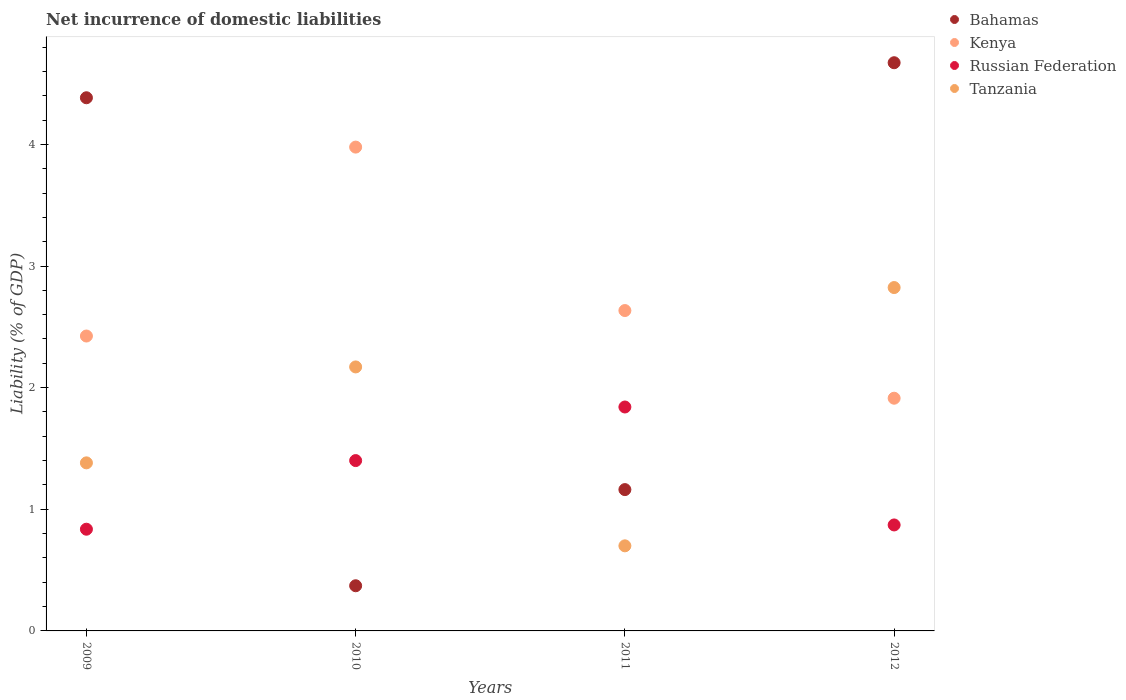How many different coloured dotlines are there?
Give a very brief answer. 4. Is the number of dotlines equal to the number of legend labels?
Provide a succinct answer. Yes. What is the net incurrence of domestic liabilities in Russian Federation in 2010?
Ensure brevity in your answer.  1.4. Across all years, what is the maximum net incurrence of domestic liabilities in Russian Federation?
Ensure brevity in your answer.  1.84. Across all years, what is the minimum net incurrence of domestic liabilities in Russian Federation?
Your answer should be compact. 0.84. In which year was the net incurrence of domestic liabilities in Tanzania maximum?
Make the answer very short. 2012. What is the total net incurrence of domestic liabilities in Tanzania in the graph?
Provide a short and direct response. 7.07. What is the difference between the net incurrence of domestic liabilities in Russian Federation in 2009 and that in 2011?
Offer a very short reply. -1. What is the difference between the net incurrence of domestic liabilities in Russian Federation in 2009 and the net incurrence of domestic liabilities in Kenya in 2012?
Offer a terse response. -1.08. What is the average net incurrence of domestic liabilities in Bahamas per year?
Keep it short and to the point. 2.65. In the year 2012, what is the difference between the net incurrence of domestic liabilities in Tanzania and net incurrence of domestic liabilities in Russian Federation?
Make the answer very short. 1.95. In how many years, is the net incurrence of domestic liabilities in Russian Federation greater than 1 %?
Offer a terse response. 2. What is the ratio of the net incurrence of domestic liabilities in Bahamas in 2010 to that in 2011?
Offer a very short reply. 0.32. What is the difference between the highest and the second highest net incurrence of domestic liabilities in Tanzania?
Your answer should be compact. 0.65. What is the difference between the highest and the lowest net incurrence of domestic liabilities in Tanzania?
Your answer should be compact. 2.12. In how many years, is the net incurrence of domestic liabilities in Bahamas greater than the average net incurrence of domestic liabilities in Bahamas taken over all years?
Your answer should be compact. 2. Is the sum of the net incurrence of domestic liabilities in Kenya in 2010 and 2012 greater than the maximum net incurrence of domestic liabilities in Bahamas across all years?
Ensure brevity in your answer.  Yes. Is it the case that in every year, the sum of the net incurrence of domestic liabilities in Kenya and net incurrence of domestic liabilities in Bahamas  is greater than the sum of net incurrence of domestic liabilities in Russian Federation and net incurrence of domestic liabilities in Tanzania?
Your answer should be very brief. Yes. Is the net incurrence of domestic liabilities in Tanzania strictly greater than the net incurrence of domestic liabilities in Russian Federation over the years?
Your answer should be compact. No. Is the net incurrence of domestic liabilities in Kenya strictly less than the net incurrence of domestic liabilities in Tanzania over the years?
Provide a succinct answer. No. How many dotlines are there?
Make the answer very short. 4. What is the difference between two consecutive major ticks on the Y-axis?
Offer a terse response. 1. Does the graph contain grids?
Offer a very short reply. No. How many legend labels are there?
Offer a very short reply. 4. What is the title of the graph?
Provide a succinct answer. Net incurrence of domestic liabilities. What is the label or title of the X-axis?
Your answer should be very brief. Years. What is the label or title of the Y-axis?
Ensure brevity in your answer.  Liability (% of GDP). What is the Liability (% of GDP) of Bahamas in 2009?
Make the answer very short. 4.38. What is the Liability (% of GDP) of Kenya in 2009?
Offer a terse response. 2.42. What is the Liability (% of GDP) in Russian Federation in 2009?
Provide a short and direct response. 0.84. What is the Liability (% of GDP) in Tanzania in 2009?
Keep it short and to the point. 1.38. What is the Liability (% of GDP) in Bahamas in 2010?
Provide a short and direct response. 0.37. What is the Liability (% of GDP) of Kenya in 2010?
Provide a succinct answer. 3.98. What is the Liability (% of GDP) of Russian Federation in 2010?
Your response must be concise. 1.4. What is the Liability (% of GDP) in Tanzania in 2010?
Offer a terse response. 2.17. What is the Liability (% of GDP) in Bahamas in 2011?
Your answer should be very brief. 1.16. What is the Liability (% of GDP) of Kenya in 2011?
Your answer should be very brief. 2.63. What is the Liability (% of GDP) of Russian Federation in 2011?
Provide a short and direct response. 1.84. What is the Liability (% of GDP) in Tanzania in 2011?
Provide a short and direct response. 0.7. What is the Liability (% of GDP) of Bahamas in 2012?
Provide a succinct answer. 4.67. What is the Liability (% of GDP) of Kenya in 2012?
Your response must be concise. 1.91. What is the Liability (% of GDP) of Russian Federation in 2012?
Provide a succinct answer. 0.87. What is the Liability (% of GDP) of Tanzania in 2012?
Provide a succinct answer. 2.82. Across all years, what is the maximum Liability (% of GDP) in Bahamas?
Your response must be concise. 4.67. Across all years, what is the maximum Liability (% of GDP) in Kenya?
Give a very brief answer. 3.98. Across all years, what is the maximum Liability (% of GDP) of Russian Federation?
Provide a short and direct response. 1.84. Across all years, what is the maximum Liability (% of GDP) of Tanzania?
Your response must be concise. 2.82. Across all years, what is the minimum Liability (% of GDP) of Bahamas?
Your answer should be very brief. 0.37. Across all years, what is the minimum Liability (% of GDP) of Kenya?
Provide a succinct answer. 1.91. Across all years, what is the minimum Liability (% of GDP) in Russian Federation?
Your answer should be very brief. 0.84. Across all years, what is the minimum Liability (% of GDP) in Tanzania?
Offer a terse response. 0.7. What is the total Liability (% of GDP) of Bahamas in the graph?
Offer a terse response. 10.59. What is the total Liability (% of GDP) in Kenya in the graph?
Your answer should be compact. 10.95. What is the total Liability (% of GDP) in Russian Federation in the graph?
Ensure brevity in your answer.  4.95. What is the total Liability (% of GDP) of Tanzania in the graph?
Offer a terse response. 7.07. What is the difference between the Liability (% of GDP) in Bahamas in 2009 and that in 2010?
Make the answer very short. 4.01. What is the difference between the Liability (% of GDP) in Kenya in 2009 and that in 2010?
Your answer should be compact. -1.55. What is the difference between the Liability (% of GDP) in Russian Federation in 2009 and that in 2010?
Provide a succinct answer. -0.56. What is the difference between the Liability (% of GDP) in Tanzania in 2009 and that in 2010?
Offer a terse response. -0.79. What is the difference between the Liability (% of GDP) in Bahamas in 2009 and that in 2011?
Your response must be concise. 3.22. What is the difference between the Liability (% of GDP) of Kenya in 2009 and that in 2011?
Make the answer very short. -0.21. What is the difference between the Liability (% of GDP) in Russian Federation in 2009 and that in 2011?
Keep it short and to the point. -1. What is the difference between the Liability (% of GDP) in Tanzania in 2009 and that in 2011?
Your answer should be very brief. 0.68. What is the difference between the Liability (% of GDP) of Bahamas in 2009 and that in 2012?
Keep it short and to the point. -0.29. What is the difference between the Liability (% of GDP) in Kenya in 2009 and that in 2012?
Keep it short and to the point. 0.51. What is the difference between the Liability (% of GDP) of Russian Federation in 2009 and that in 2012?
Give a very brief answer. -0.04. What is the difference between the Liability (% of GDP) of Tanzania in 2009 and that in 2012?
Offer a terse response. -1.44. What is the difference between the Liability (% of GDP) of Bahamas in 2010 and that in 2011?
Offer a terse response. -0.79. What is the difference between the Liability (% of GDP) of Kenya in 2010 and that in 2011?
Your answer should be compact. 1.34. What is the difference between the Liability (% of GDP) in Russian Federation in 2010 and that in 2011?
Make the answer very short. -0.44. What is the difference between the Liability (% of GDP) of Tanzania in 2010 and that in 2011?
Your answer should be compact. 1.47. What is the difference between the Liability (% of GDP) in Bahamas in 2010 and that in 2012?
Offer a terse response. -4.3. What is the difference between the Liability (% of GDP) in Kenya in 2010 and that in 2012?
Give a very brief answer. 2.06. What is the difference between the Liability (% of GDP) of Russian Federation in 2010 and that in 2012?
Give a very brief answer. 0.53. What is the difference between the Liability (% of GDP) of Tanzania in 2010 and that in 2012?
Your answer should be very brief. -0.65. What is the difference between the Liability (% of GDP) of Bahamas in 2011 and that in 2012?
Offer a terse response. -3.51. What is the difference between the Liability (% of GDP) of Kenya in 2011 and that in 2012?
Offer a very short reply. 0.72. What is the difference between the Liability (% of GDP) in Russian Federation in 2011 and that in 2012?
Your answer should be very brief. 0.97. What is the difference between the Liability (% of GDP) in Tanzania in 2011 and that in 2012?
Provide a short and direct response. -2.12. What is the difference between the Liability (% of GDP) in Bahamas in 2009 and the Liability (% of GDP) in Kenya in 2010?
Give a very brief answer. 0.41. What is the difference between the Liability (% of GDP) in Bahamas in 2009 and the Liability (% of GDP) in Russian Federation in 2010?
Your answer should be very brief. 2.98. What is the difference between the Liability (% of GDP) of Bahamas in 2009 and the Liability (% of GDP) of Tanzania in 2010?
Ensure brevity in your answer.  2.21. What is the difference between the Liability (% of GDP) in Kenya in 2009 and the Liability (% of GDP) in Tanzania in 2010?
Offer a terse response. 0.25. What is the difference between the Liability (% of GDP) of Russian Federation in 2009 and the Liability (% of GDP) of Tanzania in 2010?
Provide a short and direct response. -1.33. What is the difference between the Liability (% of GDP) of Bahamas in 2009 and the Liability (% of GDP) of Kenya in 2011?
Keep it short and to the point. 1.75. What is the difference between the Liability (% of GDP) in Bahamas in 2009 and the Liability (% of GDP) in Russian Federation in 2011?
Your answer should be compact. 2.54. What is the difference between the Liability (% of GDP) of Bahamas in 2009 and the Liability (% of GDP) of Tanzania in 2011?
Give a very brief answer. 3.68. What is the difference between the Liability (% of GDP) of Kenya in 2009 and the Liability (% of GDP) of Russian Federation in 2011?
Keep it short and to the point. 0.58. What is the difference between the Liability (% of GDP) of Kenya in 2009 and the Liability (% of GDP) of Tanzania in 2011?
Offer a terse response. 1.72. What is the difference between the Liability (% of GDP) in Russian Federation in 2009 and the Liability (% of GDP) in Tanzania in 2011?
Your response must be concise. 0.14. What is the difference between the Liability (% of GDP) in Bahamas in 2009 and the Liability (% of GDP) in Kenya in 2012?
Offer a terse response. 2.47. What is the difference between the Liability (% of GDP) of Bahamas in 2009 and the Liability (% of GDP) of Russian Federation in 2012?
Your answer should be very brief. 3.51. What is the difference between the Liability (% of GDP) of Bahamas in 2009 and the Liability (% of GDP) of Tanzania in 2012?
Your answer should be very brief. 1.56. What is the difference between the Liability (% of GDP) in Kenya in 2009 and the Liability (% of GDP) in Russian Federation in 2012?
Your response must be concise. 1.55. What is the difference between the Liability (% of GDP) in Kenya in 2009 and the Liability (% of GDP) in Tanzania in 2012?
Offer a terse response. -0.4. What is the difference between the Liability (% of GDP) of Russian Federation in 2009 and the Liability (% of GDP) of Tanzania in 2012?
Keep it short and to the point. -1.99. What is the difference between the Liability (% of GDP) of Bahamas in 2010 and the Liability (% of GDP) of Kenya in 2011?
Your answer should be compact. -2.26. What is the difference between the Liability (% of GDP) in Bahamas in 2010 and the Liability (% of GDP) in Russian Federation in 2011?
Offer a terse response. -1.47. What is the difference between the Liability (% of GDP) of Bahamas in 2010 and the Liability (% of GDP) of Tanzania in 2011?
Make the answer very short. -0.33. What is the difference between the Liability (% of GDP) in Kenya in 2010 and the Liability (% of GDP) in Russian Federation in 2011?
Your answer should be very brief. 2.14. What is the difference between the Liability (% of GDP) in Kenya in 2010 and the Liability (% of GDP) in Tanzania in 2011?
Make the answer very short. 3.28. What is the difference between the Liability (% of GDP) in Russian Federation in 2010 and the Liability (% of GDP) in Tanzania in 2011?
Provide a short and direct response. 0.7. What is the difference between the Liability (% of GDP) of Bahamas in 2010 and the Liability (% of GDP) of Kenya in 2012?
Give a very brief answer. -1.54. What is the difference between the Liability (% of GDP) of Bahamas in 2010 and the Liability (% of GDP) of Russian Federation in 2012?
Keep it short and to the point. -0.5. What is the difference between the Liability (% of GDP) in Bahamas in 2010 and the Liability (% of GDP) in Tanzania in 2012?
Your answer should be very brief. -2.45. What is the difference between the Liability (% of GDP) of Kenya in 2010 and the Liability (% of GDP) of Russian Federation in 2012?
Provide a short and direct response. 3.11. What is the difference between the Liability (% of GDP) of Kenya in 2010 and the Liability (% of GDP) of Tanzania in 2012?
Offer a very short reply. 1.15. What is the difference between the Liability (% of GDP) of Russian Federation in 2010 and the Liability (% of GDP) of Tanzania in 2012?
Provide a short and direct response. -1.42. What is the difference between the Liability (% of GDP) of Bahamas in 2011 and the Liability (% of GDP) of Kenya in 2012?
Offer a very short reply. -0.75. What is the difference between the Liability (% of GDP) of Bahamas in 2011 and the Liability (% of GDP) of Russian Federation in 2012?
Your answer should be compact. 0.29. What is the difference between the Liability (% of GDP) in Bahamas in 2011 and the Liability (% of GDP) in Tanzania in 2012?
Make the answer very short. -1.66. What is the difference between the Liability (% of GDP) in Kenya in 2011 and the Liability (% of GDP) in Russian Federation in 2012?
Keep it short and to the point. 1.76. What is the difference between the Liability (% of GDP) of Kenya in 2011 and the Liability (% of GDP) of Tanzania in 2012?
Give a very brief answer. -0.19. What is the difference between the Liability (% of GDP) of Russian Federation in 2011 and the Liability (% of GDP) of Tanzania in 2012?
Offer a very short reply. -0.98. What is the average Liability (% of GDP) of Bahamas per year?
Your answer should be compact. 2.65. What is the average Liability (% of GDP) of Kenya per year?
Offer a terse response. 2.74. What is the average Liability (% of GDP) of Russian Federation per year?
Your answer should be very brief. 1.24. What is the average Liability (% of GDP) of Tanzania per year?
Give a very brief answer. 1.77. In the year 2009, what is the difference between the Liability (% of GDP) in Bahamas and Liability (% of GDP) in Kenya?
Offer a terse response. 1.96. In the year 2009, what is the difference between the Liability (% of GDP) of Bahamas and Liability (% of GDP) of Russian Federation?
Give a very brief answer. 3.55. In the year 2009, what is the difference between the Liability (% of GDP) in Bahamas and Liability (% of GDP) in Tanzania?
Provide a succinct answer. 3. In the year 2009, what is the difference between the Liability (% of GDP) in Kenya and Liability (% of GDP) in Russian Federation?
Keep it short and to the point. 1.59. In the year 2009, what is the difference between the Liability (% of GDP) in Kenya and Liability (% of GDP) in Tanzania?
Provide a short and direct response. 1.04. In the year 2009, what is the difference between the Liability (% of GDP) of Russian Federation and Liability (% of GDP) of Tanzania?
Provide a succinct answer. -0.55. In the year 2010, what is the difference between the Liability (% of GDP) of Bahamas and Liability (% of GDP) of Kenya?
Keep it short and to the point. -3.61. In the year 2010, what is the difference between the Liability (% of GDP) in Bahamas and Liability (% of GDP) in Russian Federation?
Provide a short and direct response. -1.03. In the year 2010, what is the difference between the Liability (% of GDP) of Bahamas and Liability (% of GDP) of Tanzania?
Offer a terse response. -1.8. In the year 2010, what is the difference between the Liability (% of GDP) of Kenya and Liability (% of GDP) of Russian Federation?
Your response must be concise. 2.58. In the year 2010, what is the difference between the Liability (% of GDP) of Kenya and Liability (% of GDP) of Tanzania?
Provide a succinct answer. 1.81. In the year 2010, what is the difference between the Liability (% of GDP) in Russian Federation and Liability (% of GDP) in Tanzania?
Ensure brevity in your answer.  -0.77. In the year 2011, what is the difference between the Liability (% of GDP) of Bahamas and Liability (% of GDP) of Kenya?
Provide a short and direct response. -1.47. In the year 2011, what is the difference between the Liability (% of GDP) in Bahamas and Liability (% of GDP) in Russian Federation?
Your response must be concise. -0.68. In the year 2011, what is the difference between the Liability (% of GDP) of Bahamas and Liability (% of GDP) of Tanzania?
Make the answer very short. 0.46. In the year 2011, what is the difference between the Liability (% of GDP) of Kenya and Liability (% of GDP) of Russian Federation?
Offer a terse response. 0.79. In the year 2011, what is the difference between the Liability (% of GDP) of Kenya and Liability (% of GDP) of Tanzania?
Keep it short and to the point. 1.93. In the year 2011, what is the difference between the Liability (% of GDP) in Russian Federation and Liability (% of GDP) in Tanzania?
Give a very brief answer. 1.14. In the year 2012, what is the difference between the Liability (% of GDP) of Bahamas and Liability (% of GDP) of Kenya?
Offer a very short reply. 2.76. In the year 2012, what is the difference between the Liability (% of GDP) of Bahamas and Liability (% of GDP) of Russian Federation?
Provide a short and direct response. 3.8. In the year 2012, what is the difference between the Liability (% of GDP) in Bahamas and Liability (% of GDP) in Tanzania?
Offer a terse response. 1.85. In the year 2012, what is the difference between the Liability (% of GDP) of Kenya and Liability (% of GDP) of Russian Federation?
Your answer should be very brief. 1.04. In the year 2012, what is the difference between the Liability (% of GDP) in Kenya and Liability (% of GDP) in Tanzania?
Provide a succinct answer. -0.91. In the year 2012, what is the difference between the Liability (% of GDP) of Russian Federation and Liability (% of GDP) of Tanzania?
Provide a succinct answer. -1.95. What is the ratio of the Liability (% of GDP) of Bahamas in 2009 to that in 2010?
Ensure brevity in your answer.  11.8. What is the ratio of the Liability (% of GDP) of Kenya in 2009 to that in 2010?
Provide a succinct answer. 0.61. What is the ratio of the Liability (% of GDP) of Russian Federation in 2009 to that in 2010?
Your answer should be very brief. 0.6. What is the ratio of the Liability (% of GDP) in Tanzania in 2009 to that in 2010?
Your answer should be compact. 0.64. What is the ratio of the Liability (% of GDP) in Bahamas in 2009 to that in 2011?
Offer a very short reply. 3.77. What is the ratio of the Liability (% of GDP) of Kenya in 2009 to that in 2011?
Keep it short and to the point. 0.92. What is the ratio of the Liability (% of GDP) of Russian Federation in 2009 to that in 2011?
Provide a short and direct response. 0.45. What is the ratio of the Liability (% of GDP) in Tanzania in 2009 to that in 2011?
Offer a very short reply. 1.98. What is the ratio of the Liability (% of GDP) in Bahamas in 2009 to that in 2012?
Your response must be concise. 0.94. What is the ratio of the Liability (% of GDP) in Kenya in 2009 to that in 2012?
Your answer should be very brief. 1.27. What is the ratio of the Liability (% of GDP) in Russian Federation in 2009 to that in 2012?
Ensure brevity in your answer.  0.96. What is the ratio of the Liability (% of GDP) of Tanzania in 2009 to that in 2012?
Ensure brevity in your answer.  0.49. What is the ratio of the Liability (% of GDP) of Bahamas in 2010 to that in 2011?
Make the answer very short. 0.32. What is the ratio of the Liability (% of GDP) in Kenya in 2010 to that in 2011?
Provide a succinct answer. 1.51. What is the ratio of the Liability (% of GDP) of Russian Federation in 2010 to that in 2011?
Make the answer very short. 0.76. What is the ratio of the Liability (% of GDP) in Tanzania in 2010 to that in 2011?
Offer a terse response. 3.1. What is the ratio of the Liability (% of GDP) of Bahamas in 2010 to that in 2012?
Make the answer very short. 0.08. What is the ratio of the Liability (% of GDP) in Kenya in 2010 to that in 2012?
Your answer should be very brief. 2.08. What is the ratio of the Liability (% of GDP) of Russian Federation in 2010 to that in 2012?
Keep it short and to the point. 1.61. What is the ratio of the Liability (% of GDP) in Tanzania in 2010 to that in 2012?
Keep it short and to the point. 0.77. What is the ratio of the Liability (% of GDP) in Bahamas in 2011 to that in 2012?
Ensure brevity in your answer.  0.25. What is the ratio of the Liability (% of GDP) of Kenya in 2011 to that in 2012?
Keep it short and to the point. 1.38. What is the ratio of the Liability (% of GDP) in Russian Federation in 2011 to that in 2012?
Your response must be concise. 2.11. What is the ratio of the Liability (% of GDP) of Tanzania in 2011 to that in 2012?
Provide a short and direct response. 0.25. What is the difference between the highest and the second highest Liability (% of GDP) of Bahamas?
Keep it short and to the point. 0.29. What is the difference between the highest and the second highest Liability (% of GDP) of Kenya?
Your response must be concise. 1.34. What is the difference between the highest and the second highest Liability (% of GDP) in Russian Federation?
Offer a very short reply. 0.44. What is the difference between the highest and the second highest Liability (% of GDP) of Tanzania?
Offer a terse response. 0.65. What is the difference between the highest and the lowest Liability (% of GDP) in Bahamas?
Offer a terse response. 4.3. What is the difference between the highest and the lowest Liability (% of GDP) of Kenya?
Your answer should be very brief. 2.06. What is the difference between the highest and the lowest Liability (% of GDP) of Tanzania?
Your answer should be compact. 2.12. 